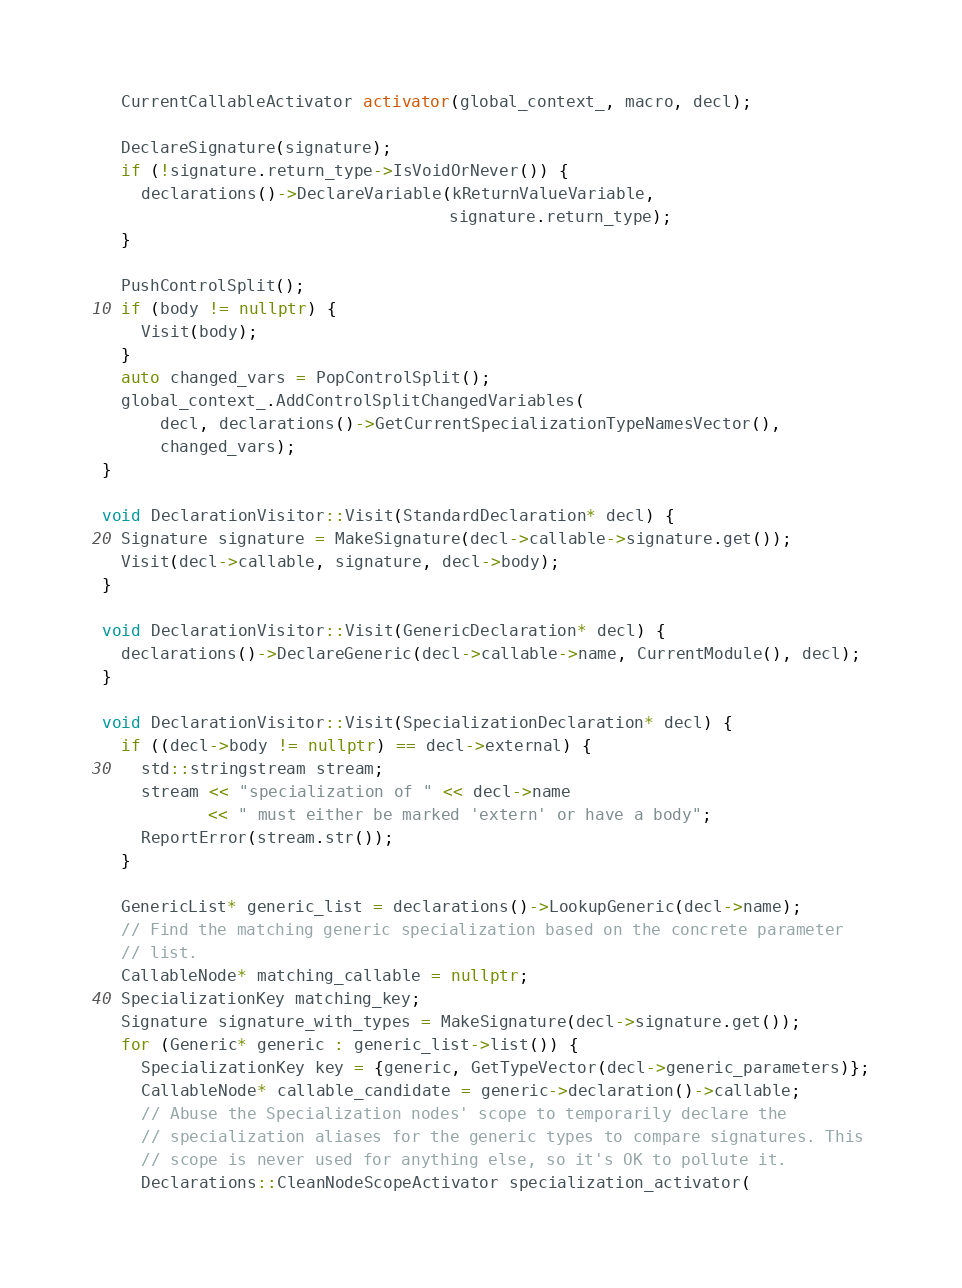Convert code to text. <code><loc_0><loc_0><loc_500><loc_500><_C++_>  CurrentCallableActivator activator(global_context_, macro, decl);

  DeclareSignature(signature);
  if (!signature.return_type->IsVoidOrNever()) {
    declarations()->DeclareVariable(kReturnValueVariable,
                                    signature.return_type);
  }

  PushControlSplit();
  if (body != nullptr) {
    Visit(body);
  }
  auto changed_vars = PopControlSplit();
  global_context_.AddControlSplitChangedVariables(
      decl, declarations()->GetCurrentSpecializationTypeNamesVector(),
      changed_vars);
}

void DeclarationVisitor::Visit(StandardDeclaration* decl) {
  Signature signature = MakeSignature(decl->callable->signature.get());
  Visit(decl->callable, signature, decl->body);
}

void DeclarationVisitor::Visit(GenericDeclaration* decl) {
  declarations()->DeclareGeneric(decl->callable->name, CurrentModule(), decl);
}

void DeclarationVisitor::Visit(SpecializationDeclaration* decl) {
  if ((decl->body != nullptr) == decl->external) {
    std::stringstream stream;
    stream << "specialization of " << decl->name
           << " must either be marked 'extern' or have a body";
    ReportError(stream.str());
  }

  GenericList* generic_list = declarations()->LookupGeneric(decl->name);
  // Find the matching generic specialization based on the concrete parameter
  // list.
  CallableNode* matching_callable = nullptr;
  SpecializationKey matching_key;
  Signature signature_with_types = MakeSignature(decl->signature.get());
  for (Generic* generic : generic_list->list()) {
    SpecializationKey key = {generic, GetTypeVector(decl->generic_parameters)};
    CallableNode* callable_candidate = generic->declaration()->callable;
    // Abuse the Specialization nodes' scope to temporarily declare the
    // specialization aliases for the generic types to compare signatures. This
    // scope is never used for anything else, so it's OK to pollute it.
    Declarations::CleanNodeScopeActivator specialization_activator(</code> 